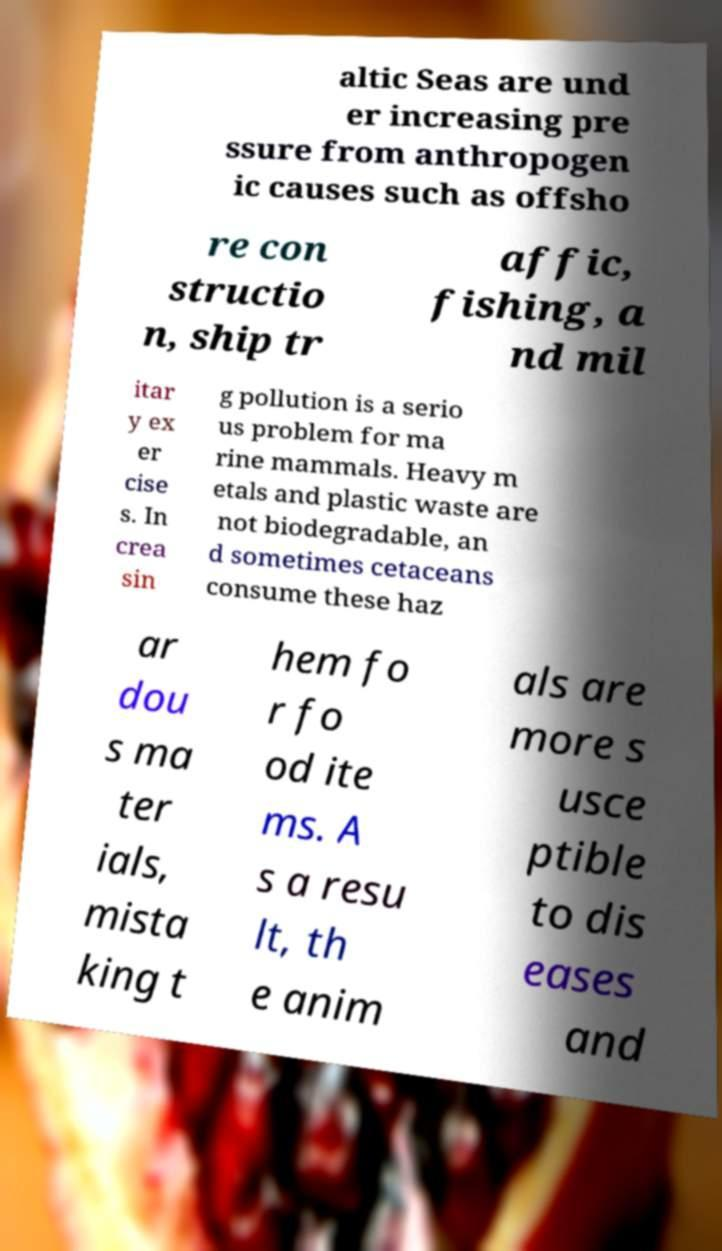There's text embedded in this image that I need extracted. Can you transcribe it verbatim? altic Seas are und er increasing pre ssure from anthropogen ic causes such as offsho re con structio n, ship tr affic, fishing, a nd mil itar y ex er cise s. In crea sin g pollution is a serio us problem for ma rine mammals. Heavy m etals and plastic waste are not biodegradable, an d sometimes cetaceans consume these haz ar dou s ma ter ials, mista king t hem fo r fo od ite ms. A s a resu lt, th e anim als are more s usce ptible to dis eases and 